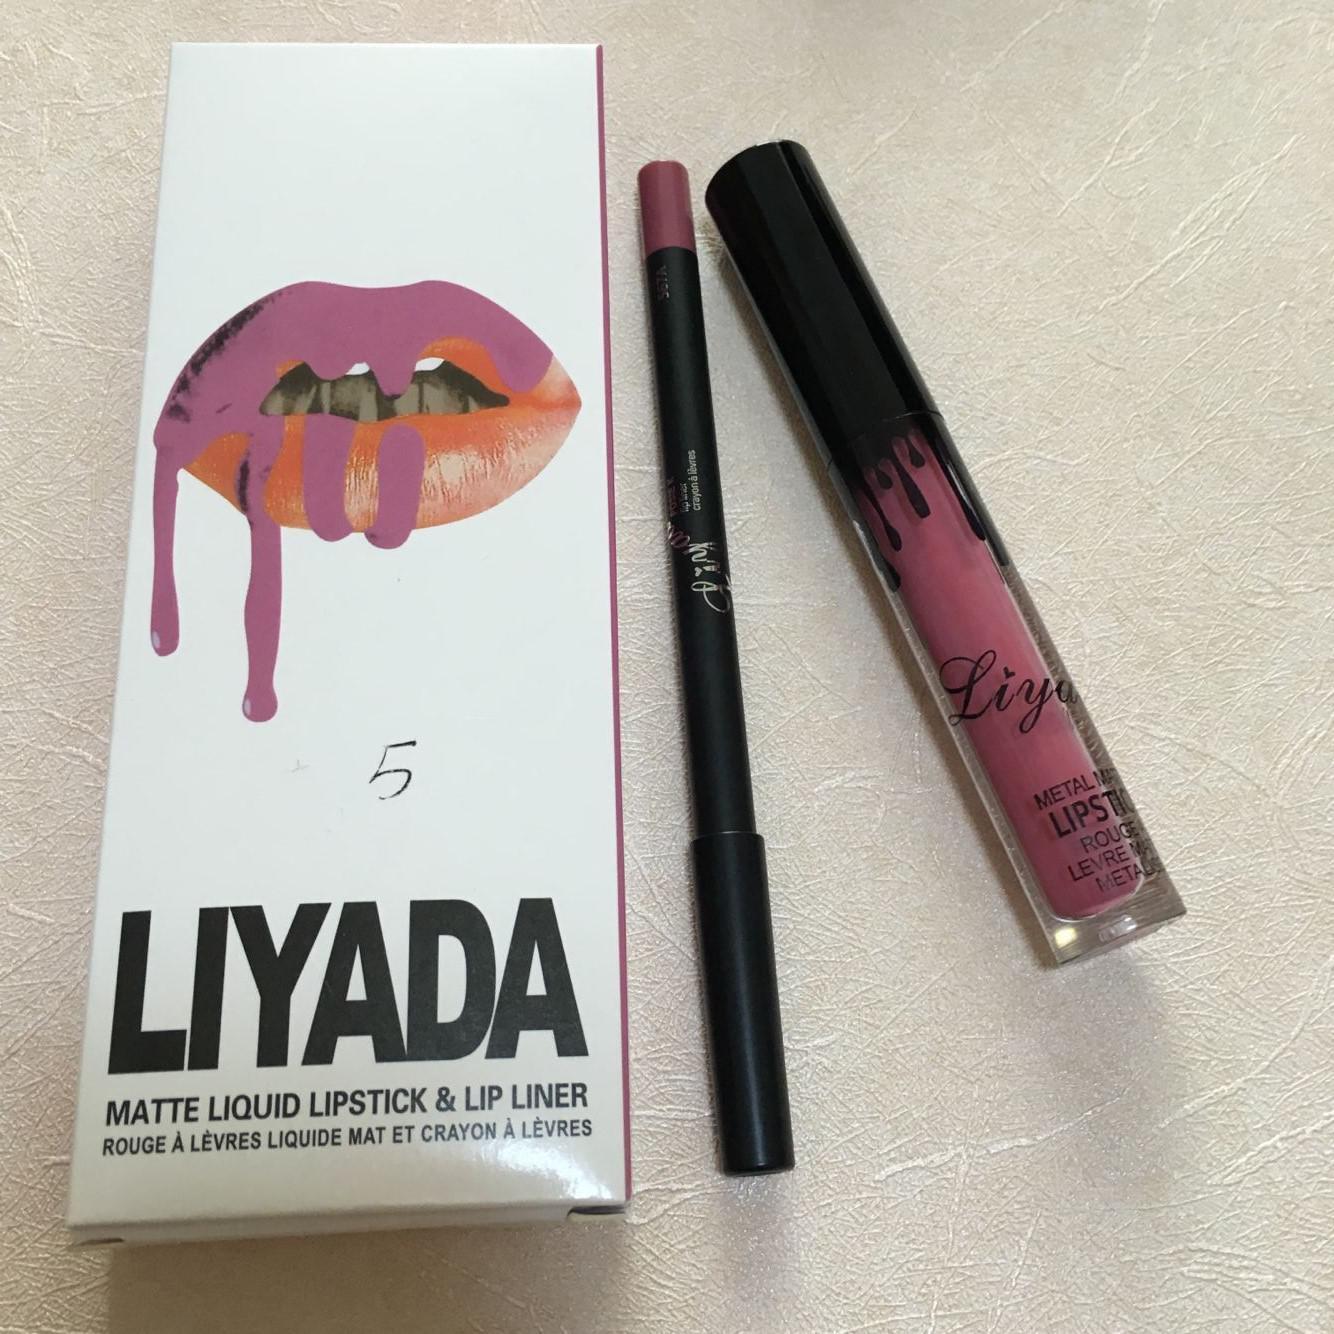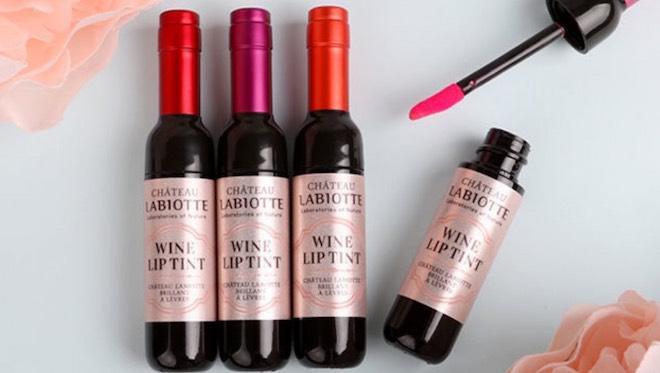The first image is the image on the left, the second image is the image on the right. Examine the images to the left and right. Is the description "An image contains lip tints in little champagne bottles." accurate? Answer yes or no. Yes. 